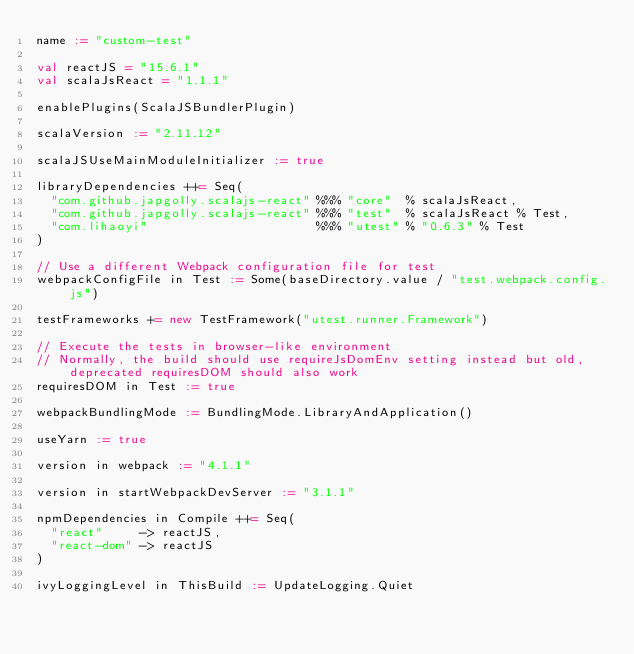Convert code to text. <code><loc_0><loc_0><loc_500><loc_500><_Scala_>name := "custom-test"

val reactJS = "15.6.1"
val scalaJsReact = "1.1.1"

enablePlugins(ScalaJSBundlerPlugin)

scalaVersion := "2.11.12"

scalaJSUseMainModuleInitializer := true

libraryDependencies ++= Seq(
  "com.github.japgolly.scalajs-react" %%% "core"  % scalaJsReact,
  "com.github.japgolly.scalajs-react" %%% "test"  % scalaJsReact % Test,
  "com.lihaoyi"                       %%% "utest" % "0.6.3" % Test
)

// Use a different Webpack configuration file for test
webpackConfigFile in Test := Some(baseDirectory.value / "test.webpack.config.js")

testFrameworks += new TestFramework("utest.runner.Framework")

// Execute the tests in browser-like environment
// Normally, the build should use requireJsDomEnv setting instead but old, deprecated requiresDOM should also work
requiresDOM in Test := true

webpackBundlingMode := BundlingMode.LibraryAndApplication()

useYarn := true

version in webpack := "4.1.1"

version in startWebpackDevServer := "3.1.1"

npmDependencies in Compile ++= Seq(
  "react"     -> reactJS,
  "react-dom" -> reactJS
)

ivyLoggingLevel in ThisBuild := UpdateLogging.Quiet
</code> 